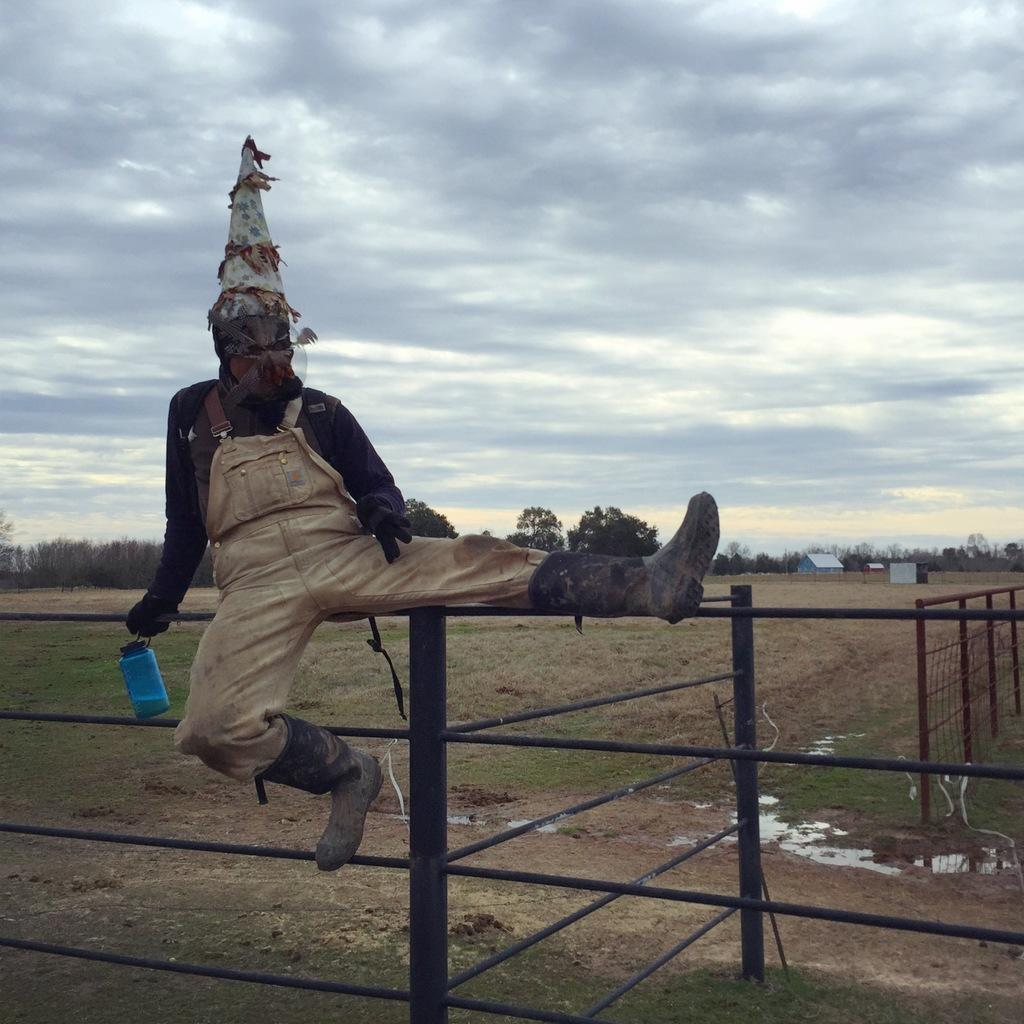What is the person in the image doing? The person is sitting on a fence. What is the person holding in his hand? The person is holding a jar in his hand. What can be seen in the background of the image? There are trees in the background of the image. What type of structures are visible on the right side of the image? There are houses on the right side of the image. What is visible in the sky in the image? Clouds are visible in the sky. What type of potato is being used as a cause in the image? There is no potato present in the image, and no cause is depicted. 